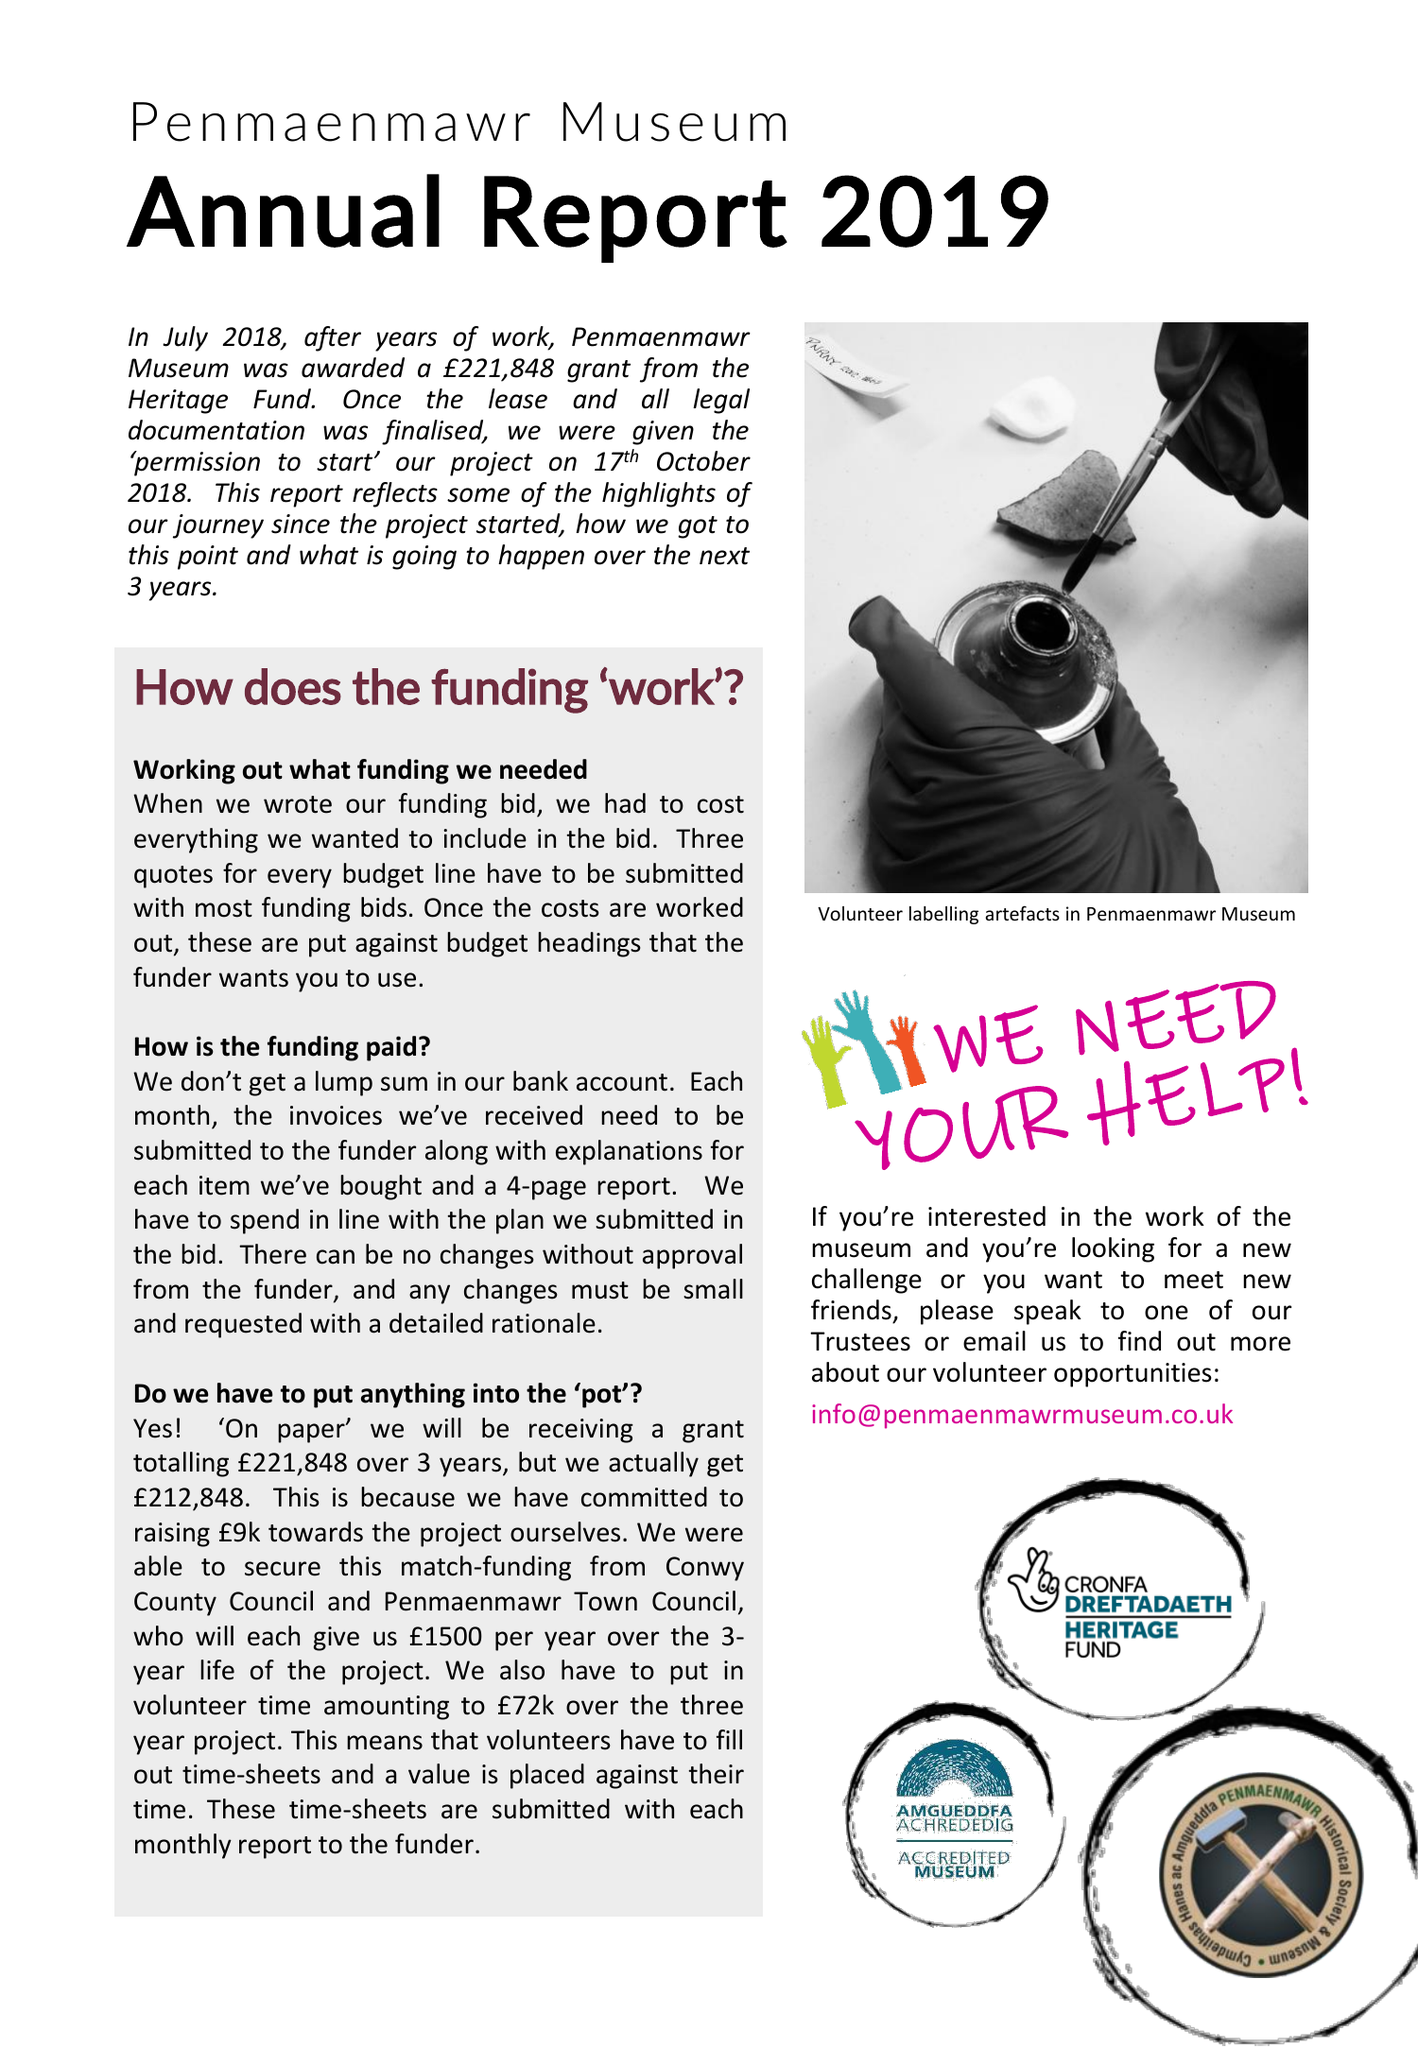What is the value for the address__postcode?
Answer the question using a single word or phrase. LL34 6UT 